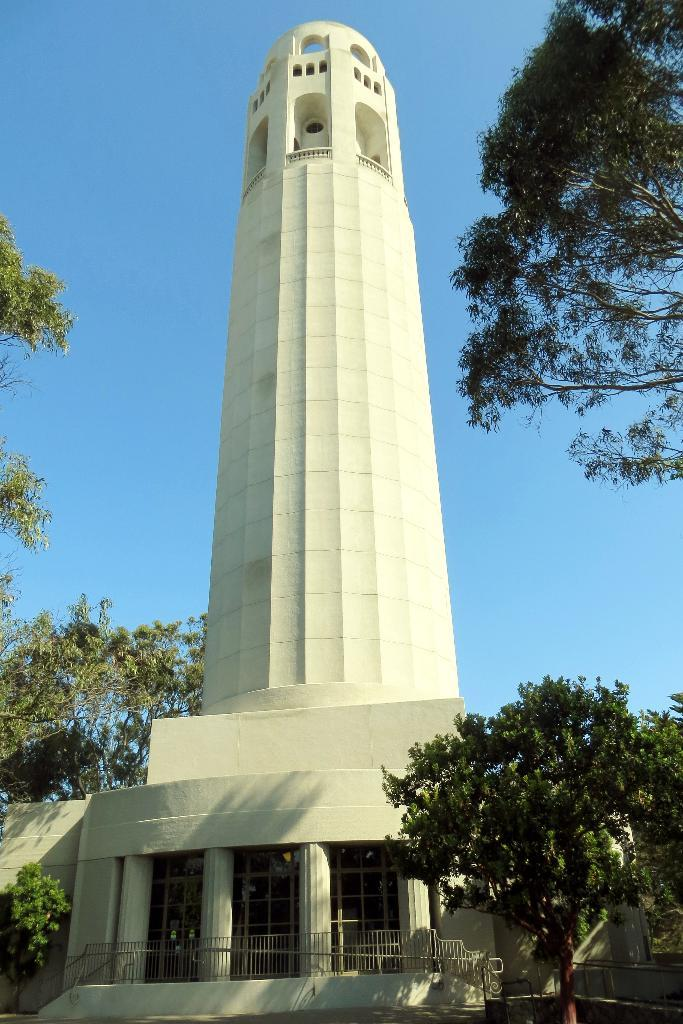What is the main structure in the image? There is a tower in the image. What is in front of the tower? There are pillars with a metal rod fence in front of the tower. What type of vegetation can be seen in the image? There are trees visible in the image. Can you see any guns being used in the image? There are no guns visible in the image. Is there any evidence of a crime happening in the image? There is no indication of a crime in the image. 